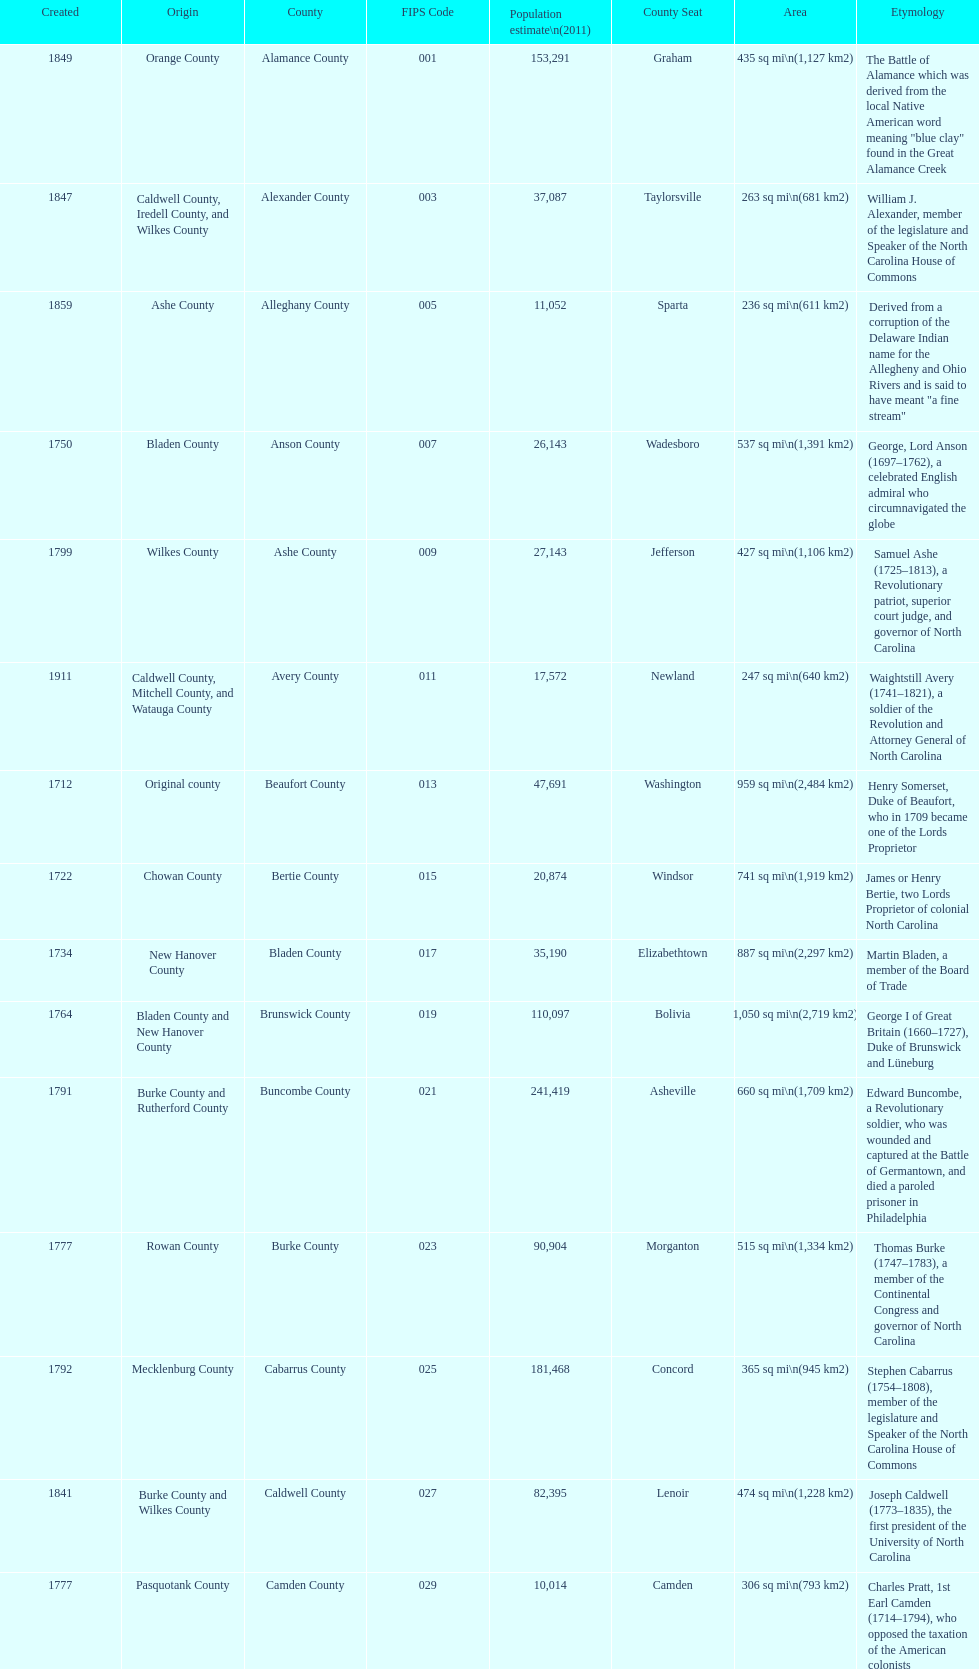What is the total number of counties listed? 100. 